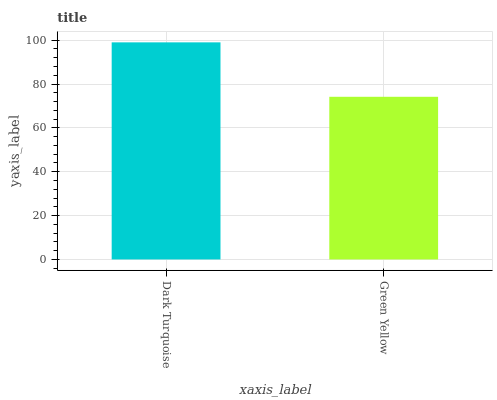Is Green Yellow the minimum?
Answer yes or no. Yes. Is Dark Turquoise the maximum?
Answer yes or no. Yes. Is Green Yellow the maximum?
Answer yes or no. No. Is Dark Turquoise greater than Green Yellow?
Answer yes or no. Yes. Is Green Yellow less than Dark Turquoise?
Answer yes or no. Yes. Is Green Yellow greater than Dark Turquoise?
Answer yes or no. No. Is Dark Turquoise less than Green Yellow?
Answer yes or no. No. Is Dark Turquoise the high median?
Answer yes or no. Yes. Is Green Yellow the low median?
Answer yes or no. Yes. Is Green Yellow the high median?
Answer yes or no. No. Is Dark Turquoise the low median?
Answer yes or no. No. 